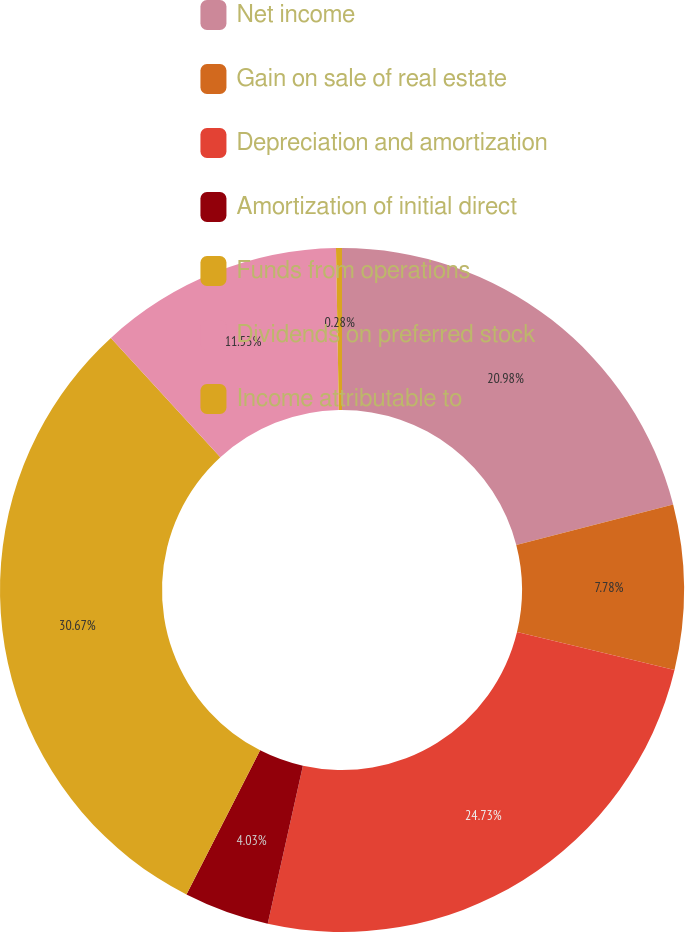<chart> <loc_0><loc_0><loc_500><loc_500><pie_chart><fcel>Net income<fcel>Gain on sale of real estate<fcel>Depreciation and amortization<fcel>Amortization of initial direct<fcel>Funds from operations<fcel>Dividends on preferred stock<fcel>Income attributable to<nl><fcel>20.98%<fcel>7.78%<fcel>24.73%<fcel>4.03%<fcel>30.68%<fcel>11.53%<fcel>0.28%<nl></chart> 